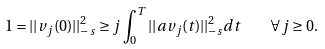<formula> <loc_0><loc_0><loc_500><loc_500>1 = | | v _ { j } ( 0 ) | | ^ { 2 } _ { - s } \geq j \int _ { 0 } ^ { T } | | a v _ { j } ( t ) | | ^ { 2 } _ { - s } d t \quad \forall j \geq 0 .</formula> 